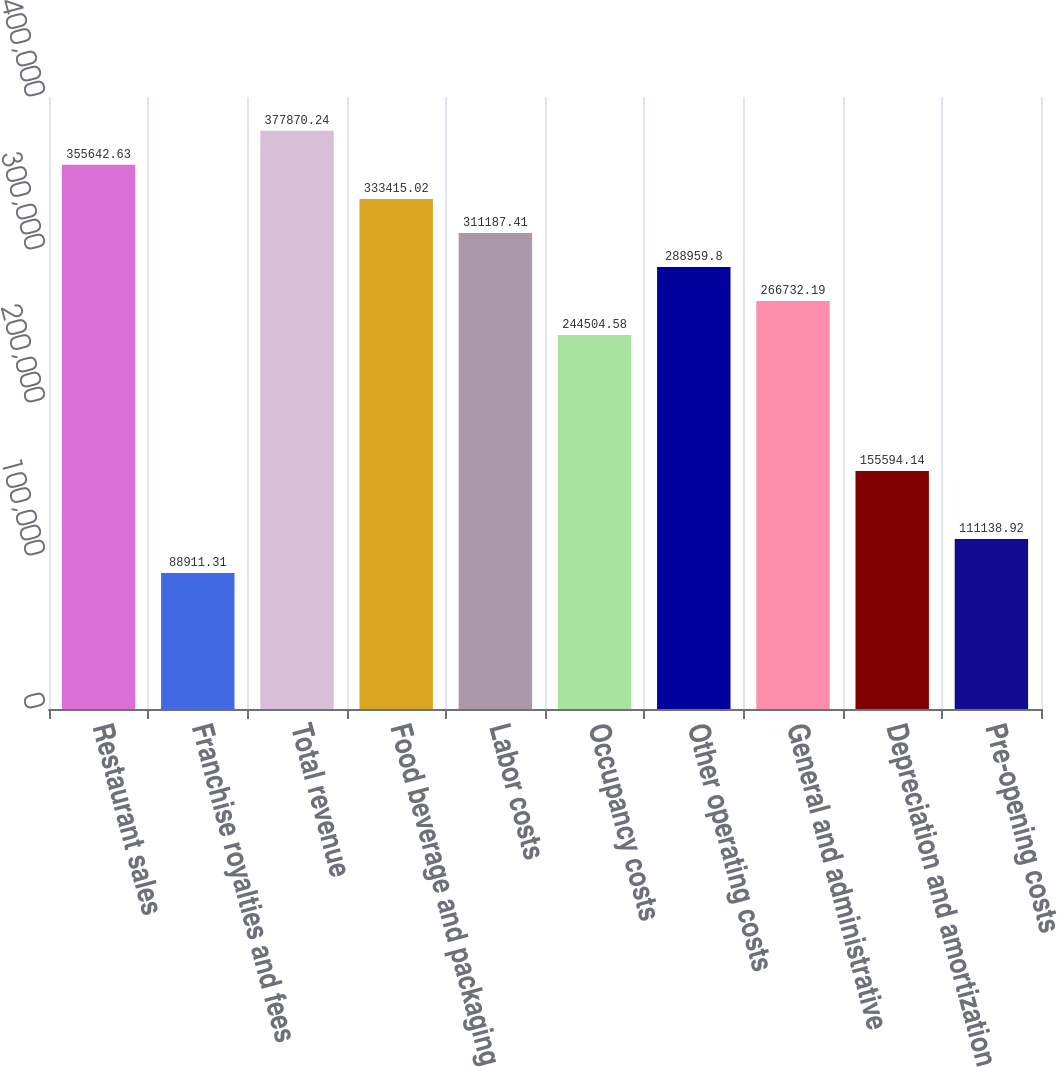Convert chart to OTSL. <chart><loc_0><loc_0><loc_500><loc_500><bar_chart><fcel>Restaurant sales<fcel>Franchise royalties and fees<fcel>Total revenue<fcel>Food beverage and packaging<fcel>Labor costs<fcel>Occupancy costs<fcel>Other operating costs<fcel>General and administrative<fcel>Depreciation and amortization<fcel>Pre-opening costs<nl><fcel>355643<fcel>88911.3<fcel>377870<fcel>333415<fcel>311187<fcel>244505<fcel>288960<fcel>266732<fcel>155594<fcel>111139<nl></chart> 